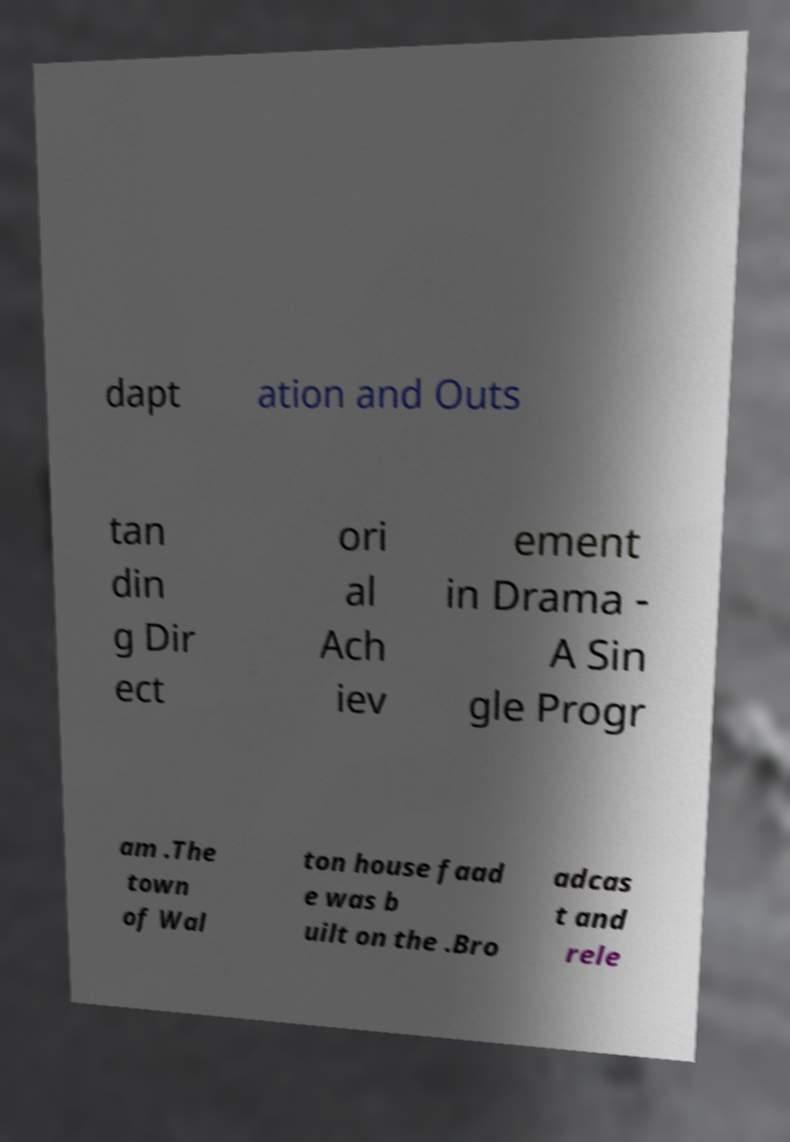What messages or text are displayed in this image? I need them in a readable, typed format. dapt ation and Outs tan din g Dir ect ori al Ach iev ement in Drama - A Sin gle Progr am .The town of Wal ton house faad e was b uilt on the .Bro adcas t and rele 